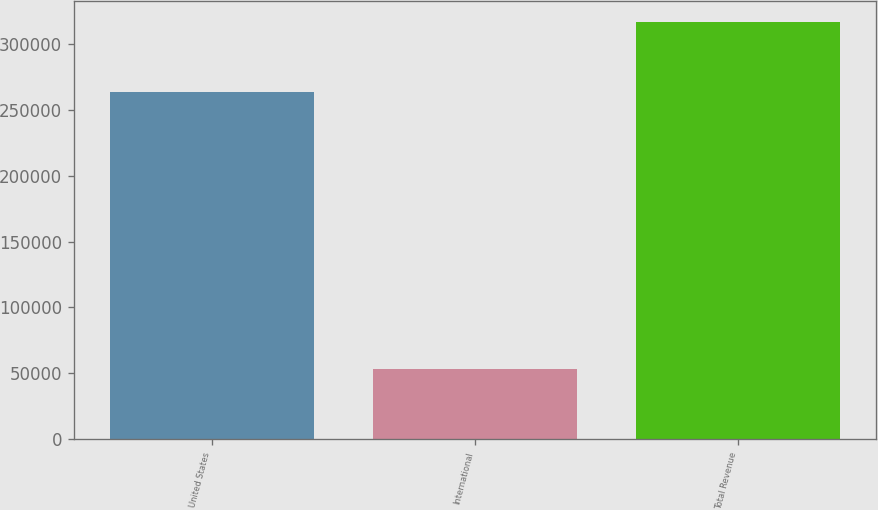Convert chart to OTSL. <chart><loc_0><loc_0><loc_500><loc_500><bar_chart><fcel>United States<fcel>International<fcel>Total Revenue<nl><fcel>263917<fcel>53016<fcel>316933<nl></chart> 